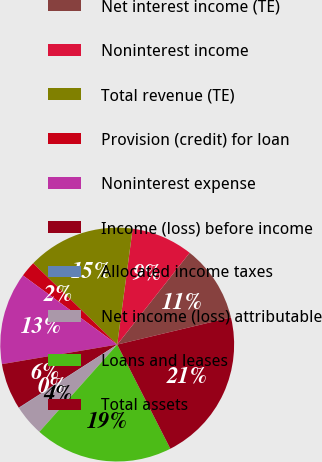Convert chart to OTSL. <chart><loc_0><loc_0><loc_500><loc_500><pie_chart><fcel>Net interest income (TE)<fcel>Noninterest income<fcel>Total revenue (TE)<fcel>Provision (credit) for loan<fcel>Noninterest expense<fcel>Income (loss) before income<fcel>Allocated income taxes<fcel>Net income (loss) attributable<fcel>Loans and leases<fcel>Total assets<nl><fcel>10.64%<fcel>8.52%<fcel>14.87%<fcel>2.17%<fcel>12.75%<fcel>6.4%<fcel>0.05%<fcel>4.28%<fcel>19.1%<fcel>21.22%<nl></chart> 